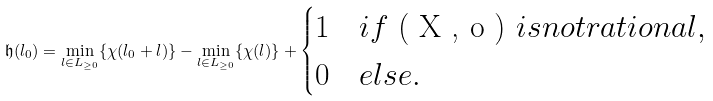<formula> <loc_0><loc_0><loc_500><loc_500>\mathfrak { h } ( l _ { 0 } ) = \min _ { l \in L _ { \geq 0 } } \{ \chi ( l _ { 0 } + l ) \} - \min _ { l \in L _ { \geq 0 } } \{ \chi ( l ) \} + \begin{cases} 1 & i f $ ( X , o ) $ i s n o t r a t i o n a l , \\ 0 & e l s e . \end{cases}</formula> 